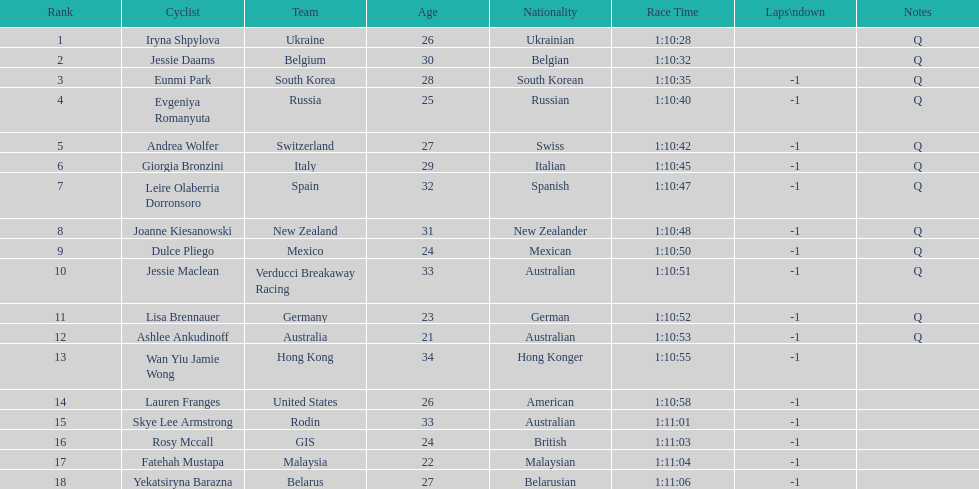What is the number rank of belgium? 2. 